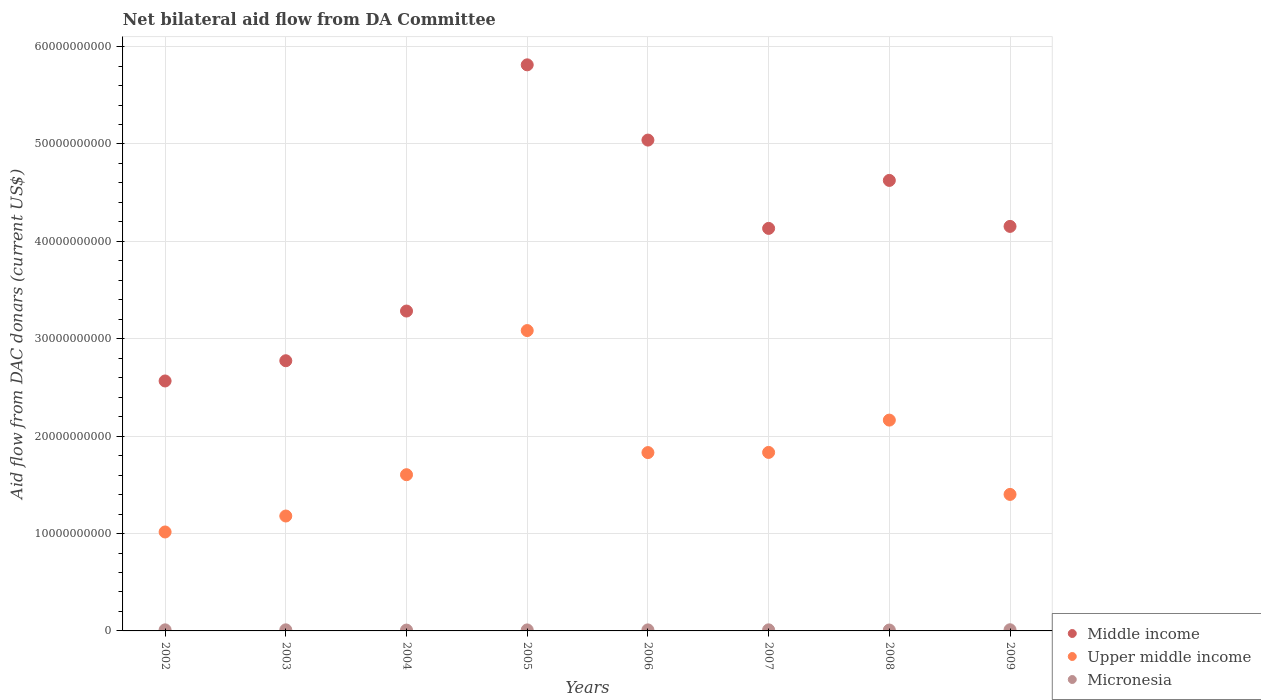Is the number of dotlines equal to the number of legend labels?
Make the answer very short. Yes. What is the aid flow in in Upper middle income in 2004?
Offer a terse response. 1.60e+1. Across all years, what is the maximum aid flow in in Middle income?
Offer a very short reply. 5.81e+1. Across all years, what is the minimum aid flow in in Middle income?
Provide a succinct answer. 2.57e+1. In which year was the aid flow in in Upper middle income maximum?
Offer a terse response. 2005. In which year was the aid flow in in Upper middle income minimum?
Make the answer very short. 2002. What is the total aid flow in in Upper middle income in the graph?
Your response must be concise. 1.41e+11. What is the difference between the aid flow in in Middle income in 2002 and that in 2004?
Offer a very short reply. -7.18e+09. What is the difference between the aid flow in in Micronesia in 2004 and the aid flow in in Middle income in 2008?
Make the answer very short. -4.62e+1. What is the average aid flow in in Upper middle income per year?
Give a very brief answer. 1.76e+1. In the year 2006, what is the difference between the aid flow in in Upper middle income and aid flow in in Micronesia?
Give a very brief answer. 1.82e+1. In how many years, is the aid flow in in Micronesia greater than 24000000000 US$?
Provide a succinct answer. 0. What is the ratio of the aid flow in in Middle income in 2006 to that in 2008?
Your response must be concise. 1.09. Is the aid flow in in Middle income in 2005 less than that in 2007?
Provide a short and direct response. No. What is the difference between the highest and the second highest aid flow in in Middle income?
Your answer should be very brief. 7.73e+09. What is the difference between the highest and the lowest aid flow in in Middle income?
Provide a short and direct response. 3.25e+1. In how many years, is the aid flow in in Micronesia greater than the average aid flow in in Micronesia taken over all years?
Offer a terse response. 5. Is it the case that in every year, the sum of the aid flow in in Middle income and aid flow in in Upper middle income  is greater than the aid flow in in Micronesia?
Your response must be concise. Yes. Is the aid flow in in Middle income strictly less than the aid flow in in Micronesia over the years?
Offer a terse response. No. What is the difference between two consecutive major ticks on the Y-axis?
Give a very brief answer. 1.00e+1. Are the values on the major ticks of Y-axis written in scientific E-notation?
Keep it short and to the point. No. Does the graph contain grids?
Offer a very short reply. Yes. How many legend labels are there?
Provide a succinct answer. 3. What is the title of the graph?
Ensure brevity in your answer.  Net bilateral aid flow from DA Committee. Does "Croatia" appear as one of the legend labels in the graph?
Keep it short and to the point. No. What is the label or title of the X-axis?
Give a very brief answer. Years. What is the label or title of the Y-axis?
Provide a short and direct response. Aid flow from DAC donars (current US$). What is the Aid flow from DAC donars (current US$) of Middle income in 2002?
Your answer should be compact. 2.57e+1. What is the Aid flow from DAC donars (current US$) in Upper middle income in 2002?
Your response must be concise. 1.02e+1. What is the Aid flow from DAC donars (current US$) of Micronesia in 2002?
Your answer should be very brief. 1.10e+08. What is the Aid flow from DAC donars (current US$) in Middle income in 2003?
Offer a very short reply. 2.77e+1. What is the Aid flow from DAC donars (current US$) in Upper middle income in 2003?
Your response must be concise. 1.18e+1. What is the Aid flow from DAC donars (current US$) in Micronesia in 2003?
Provide a short and direct response. 1.12e+08. What is the Aid flow from DAC donars (current US$) in Middle income in 2004?
Ensure brevity in your answer.  3.28e+1. What is the Aid flow from DAC donars (current US$) of Upper middle income in 2004?
Keep it short and to the point. 1.60e+1. What is the Aid flow from DAC donars (current US$) in Micronesia in 2004?
Your response must be concise. 8.52e+07. What is the Aid flow from DAC donars (current US$) in Middle income in 2005?
Keep it short and to the point. 5.81e+1. What is the Aid flow from DAC donars (current US$) in Upper middle income in 2005?
Your answer should be compact. 3.08e+1. What is the Aid flow from DAC donars (current US$) of Micronesia in 2005?
Make the answer very short. 1.04e+08. What is the Aid flow from DAC donars (current US$) of Middle income in 2006?
Offer a terse response. 5.04e+1. What is the Aid flow from DAC donars (current US$) of Upper middle income in 2006?
Offer a terse response. 1.83e+1. What is the Aid flow from DAC donars (current US$) of Micronesia in 2006?
Your answer should be compact. 1.06e+08. What is the Aid flow from DAC donars (current US$) in Middle income in 2007?
Offer a very short reply. 4.13e+1. What is the Aid flow from DAC donars (current US$) in Upper middle income in 2007?
Your answer should be very brief. 1.83e+1. What is the Aid flow from DAC donars (current US$) in Micronesia in 2007?
Offer a terse response. 1.11e+08. What is the Aid flow from DAC donars (current US$) of Middle income in 2008?
Provide a succinct answer. 4.63e+1. What is the Aid flow from DAC donars (current US$) in Upper middle income in 2008?
Your response must be concise. 2.16e+1. What is the Aid flow from DAC donars (current US$) of Micronesia in 2008?
Keep it short and to the point. 9.08e+07. What is the Aid flow from DAC donars (current US$) in Middle income in 2009?
Offer a terse response. 4.15e+1. What is the Aid flow from DAC donars (current US$) in Upper middle income in 2009?
Offer a terse response. 1.40e+1. What is the Aid flow from DAC donars (current US$) of Micronesia in 2009?
Make the answer very short. 1.21e+08. Across all years, what is the maximum Aid flow from DAC donars (current US$) in Middle income?
Your response must be concise. 5.81e+1. Across all years, what is the maximum Aid flow from DAC donars (current US$) of Upper middle income?
Give a very brief answer. 3.08e+1. Across all years, what is the maximum Aid flow from DAC donars (current US$) of Micronesia?
Ensure brevity in your answer.  1.21e+08. Across all years, what is the minimum Aid flow from DAC donars (current US$) of Middle income?
Offer a terse response. 2.57e+1. Across all years, what is the minimum Aid flow from DAC donars (current US$) of Upper middle income?
Offer a terse response. 1.02e+1. Across all years, what is the minimum Aid flow from DAC donars (current US$) of Micronesia?
Keep it short and to the point. 8.52e+07. What is the total Aid flow from DAC donars (current US$) in Middle income in the graph?
Your answer should be very brief. 3.24e+11. What is the total Aid flow from DAC donars (current US$) in Upper middle income in the graph?
Offer a terse response. 1.41e+11. What is the total Aid flow from DAC donars (current US$) in Micronesia in the graph?
Provide a succinct answer. 8.41e+08. What is the difference between the Aid flow from DAC donars (current US$) of Middle income in 2002 and that in 2003?
Offer a terse response. -2.08e+09. What is the difference between the Aid flow from DAC donars (current US$) of Upper middle income in 2002 and that in 2003?
Your answer should be compact. -1.64e+09. What is the difference between the Aid flow from DAC donars (current US$) of Micronesia in 2002 and that in 2003?
Give a very brief answer. -1.82e+06. What is the difference between the Aid flow from DAC donars (current US$) of Middle income in 2002 and that in 2004?
Your answer should be very brief. -7.18e+09. What is the difference between the Aid flow from DAC donars (current US$) of Upper middle income in 2002 and that in 2004?
Your answer should be compact. -5.88e+09. What is the difference between the Aid flow from DAC donars (current US$) of Micronesia in 2002 and that in 2004?
Provide a short and direct response. 2.49e+07. What is the difference between the Aid flow from DAC donars (current US$) of Middle income in 2002 and that in 2005?
Provide a short and direct response. -3.25e+1. What is the difference between the Aid flow from DAC donars (current US$) of Upper middle income in 2002 and that in 2005?
Keep it short and to the point. -2.07e+1. What is the difference between the Aid flow from DAC donars (current US$) in Micronesia in 2002 and that in 2005?
Keep it short and to the point. 5.66e+06. What is the difference between the Aid flow from DAC donars (current US$) of Middle income in 2002 and that in 2006?
Make the answer very short. -2.47e+1. What is the difference between the Aid flow from DAC donars (current US$) of Upper middle income in 2002 and that in 2006?
Your response must be concise. -8.15e+09. What is the difference between the Aid flow from DAC donars (current US$) of Micronesia in 2002 and that in 2006?
Give a very brief answer. 4.03e+06. What is the difference between the Aid flow from DAC donars (current US$) of Middle income in 2002 and that in 2007?
Offer a very short reply. -1.57e+1. What is the difference between the Aid flow from DAC donars (current US$) in Upper middle income in 2002 and that in 2007?
Keep it short and to the point. -8.17e+09. What is the difference between the Aid flow from DAC donars (current US$) of Micronesia in 2002 and that in 2007?
Your answer should be compact. -1.27e+06. What is the difference between the Aid flow from DAC donars (current US$) of Middle income in 2002 and that in 2008?
Offer a terse response. -2.06e+1. What is the difference between the Aid flow from DAC donars (current US$) of Upper middle income in 2002 and that in 2008?
Provide a succinct answer. -1.15e+1. What is the difference between the Aid flow from DAC donars (current US$) in Micronesia in 2002 and that in 2008?
Provide a short and direct response. 1.92e+07. What is the difference between the Aid flow from DAC donars (current US$) of Middle income in 2002 and that in 2009?
Make the answer very short. -1.59e+1. What is the difference between the Aid flow from DAC donars (current US$) of Upper middle income in 2002 and that in 2009?
Give a very brief answer. -3.86e+09. What is the difference between the Aid flow from DAC donars (current US$) in Micronesia in 2002 and that in 2009?
Offer a very short reply. -1.08e+07. What is the difference between the Aid flow from DAC donars (current US$) in Middle income in 2003 and that in 2004?
Your answer should be compact. -5.10e+09. What is the difference between the Aid flow from DAC donars (current US$) of Upper middle income in 2003 and that in 2004?
Provide a short and direct response. -4.24e+09. What is the difference between the Aid flow from DAC donars (current US$) in Micronesia in 2003 and that in 2004?
Keep it short and to the point. 2.67e+07. What is the difference between the Aid flow from DAC donars (current US$) of Middle income in 2003 and that in 2005?
Make the answer very short. -3.04e+1. What is the difference between the Aid flow from DAC donars (current US$) of Upper middle income in 2003 and that in 2005?
Keep it short and to the point. -1.90e+1. What is the difference between the Aid flow from DAC donars (current US$) in Micronesia in 2003 and that in 2005?
Make the answer very short. 7.48e+06. What is the difference between the Aid flow from DAC donars (current US$) in Middle income in 2003 and that in 2006?
Provide a succinct answer. -2.27e+1. What is the difference between the Aid flow from DAC donars (current US$) of Upper middle income in 2003 and that in 2006?
Make the answer very short. -6.51e+09. What is the difference between the Aid flow from DAC donars (current US$) of Micronesia in 2003 and that in 2006?
Make the answer very short. 5.85e+06. What is the difference between the Aid flow from DAC donars (current US$) of Middle income in 2003 and that in 2007?
Ensure brevity in your answer.  -1.36e+1. What is the difference between the Aid flow from DAC donars (current US$) in Upper middle income in 2003 and that in 2007?
Your response must be concise. -6.53e+09. What is the difference between the Aid flow from DAC donars (current US$) of Micronesia in 2003 and that in 2007?
Offer a very short reply. 5.50e+05. What is the difference between the Aid flow from DAC donars (current US$) of Middle income in 2003 and that in 2008?
Provide a succinct answer. -1.85e+1. What is the difference between the Aid flow from DAC donars (current US$) of Upper middle income in 2003 and that in 2008?
Keep it short and to the point. -9.85e+09. What is the difference between the Aid flow from DAC donars (current US$) in Micronesia in 2003 and that in 2008?
Give a very brief answer. 2.10e+07. What is the difference between the Aid flow from DAC donars (current US$) in Middle income in 2003 and that in 2009?
Ensure brevity in your answer.  -1.38e+1. What is the difference between the Aid flow from DAC donars (current US$) in Upper middle income in 2003 and that in 2009?
Make the answer very short. -2.22e+09. What is the difference between the Aid flow from DAC donars (current US$) in Micronesia in 2003 and that in 2009?
Ensure brevity in your answer.  -9.02e+06. What is the difference between the Aid flow from DAC donars (current US$) of Middle income in 2004 and that in 2005?
Provide a succinct answer. -2.53e+1. What is the difference between the Aid flow from DAC donars (current US$) of Upper middle income in 2004 and that in 2005?
Make the answer very short. -1.48e+1. What is the difference between the Aid flow from DAC donars (current US$) in Micronesia in 2004 and that in 2005?
Your response must be concise. -1.92e+07. What is the difference between the Aid flow from DAC donars (current US$) in Middle income in 2004 and that in 2006?
Make the answer very short. -1.76e+1. What is the difference between the Aid flow from DAC donars (current US$) in Upper middle income in 2004 and that in 2006?
Your answer should be very brief. -2.27e+09. What is the difference between the Aid flow from DAC donars (current US$) of Micronesia in 2004 and that in 2006?
Your answer should be compact. -2.09e+07. What is the difference between the Aid flow from DAC donars (current US$) in Middle income in 2004 and that in 2007?
Your answer should be very brief. -8.49e+09. What is the difference between the Aid flow from DAC donars (current US$) of Upper middle income in 2004 and that in 2007?
Provide a succinct answer. -2.29e+09. What is the difference between the Aid flow from DAC donars (current US$) in Micronesia in 2004 and that in 2007?
Offer a terse response. -2.62e+07. What is the difference between the Aid flow from DAC donars (current US$) of Middle income in 2004 and that in 2008?
Keep it short and to the point. -1.34e+1. What is the difference between the Aid flow from DAC donars (current US$) in Upper middle income in 2004 and that in 2008?
Your answer should be compact. -5.61e+09. What is the difference between the Aid flow from DAC donars (current US$) in Micronesia in 2004 and that in 2008?
Provide a succinct answer. -5.68e+06. What is the difference between the Aid flow from DAC donars (current US$) in Middle income in 2004 and that in 2009?
Provide a short and direct response. -8.69e+09. What is the difference between the Aid flow from DAC donars (current US$) of Upper middle income in 2004 and that in 2009?
Provide a short and direct response. 2.02e+09. What is the difference between the Aid flow from DAC donars (current US$) in Micronesia in 2004 and that in 2009?
Offer a terse response. -3.57e+07. What is the difference between the Aid flow from DAC donars (current US$) of Middle income in 2005 and that in 2006?
Ensure brevity in your answer.  7.73e+09. What is the difference between the Aid flow from DAC donars (current US$) in Upper middle income in 2005 and that in 2006?
Make the answer very short. 1.25e+1. What is the difference between the Aid flow from DAC donars (current US$) of Micronesia in 2005 and that in 2006?
Offer a terse response. -1.63e+06. What is the difference between the Aid flow from DAC donars (current US$) of Middle income in 2005 and that in 2007?
Your answer should be very brief. 1.68e+1. What is the difference between the Aid flow from DAC donars (current US$) of Upper middle income in 2005 and that in 2007?
Your answer should be compact. 1.25e+1. What is the difference between the Aid flow from DAC donars (current US$) of Micronesia in 2005 and that in 2007?
Your answer should be compact. -6.93e+06. What is the difference between the Aid flow from DAC donars (current US$) in Middle income in 2005 and that in 2008?
Keep it short and to the point. 1.19e+1. What is the difference between the Aid flow from DAC donars (current US$) of Upper middle income in 2005 and that in 2008?
Offer a very short reply. 9.19e+09. What is the difference between the Aid flow from DAC donars (current US$) in Micronesia in 2005 and that in 2008?
Offer a terse response. 1.36e+07. What is the difference between the Aid flow from DAC donars (current US$) in Middle income in 2005 and that in 2009?
Ensure brevity in your answer.  1.66e+1. What is the difference between the Aid flow from DAC donars (current US$) in Upper middle income in 2005 and that in 2009?
Your answer should be very brief. 1.68e+1. What is the difference between the Aid flow from DAC donars (current US$) in Micronesia in 2005 and that in 2009?
Provide a succinct answer. -1.65e+07. What is the difference between the Aid flow from DAC donars (current US$) in Middle income in 2006 and that in 2007?
Offer a very short reply. 9.07e+09. What is the difference between the Aid flow from DAC donars (current US$) of Upper middle income in 2006 and that in 2007?
Keep it short and to the point. -1.82e+07. What is the difference between the Aid flow from DAC donars (current US$) of Micronesia in 2006 and that in 2007?
Your answer should be compact. -5.30e+06. What is the difference between the Aid flow from DAC donars (current US$) in Middle income in 2006 and that in 2008?
Your response must be concise. 4.14e+09. What is the difference between the Aid flow from DAC donars (current US$) in Upper middle income in 2006 and that in 2008?
Your answer should be compact. -3.34e+09. What is the difference between the Aid flow from DAC donars (current US$) in Micronesia in 2006 and that in 2008?
Provide a short and direct response. 1.52e+07. What is the difference between the Aid flow from DAC donars (current US$) of Middle income in 2006 and that in 2009?
Provide a short and direct response. 8.86e+09. What is the difference between the Aid flow from DAC donars (current US$) of Upper middle income in 2006 and that in 2009?
Offer a very short reply. 4.29e+09. What is the difference between the Aid flow from DAC donars (current US$) in Micronesia in 2006 and that in 2009?
Keep it short and to the point. -1.49e+07. What is the difference between the Aid flow from DAC donars (current US$) of Middle income in 2007 and that in 2008?
Provide a short and direct response. -4.93e+09. What is the difference between the Aid flow from DAC donars (current US$) of Upper middle income in 2007 and that in 2008?
Give a very brief answer. -3.32e+09. What is the difference between the Aid flow from DAC donars (current US$) of Micronesia in 2007 and that in 2008?
Give a very brief answer. 2.05e+07. What is the difference between the Aid flow from DAC donars (current US$) of Middle income in 2007 and that in 2009?
Offer a terse response. -2.05e+08. What is the difference between the Aid flow from DAC donars (current US$) of Upper middle income in 2007 and that in 2009?
Give a very brief answer. 4.31e+09. What is the difference between the Aid flow from DAC donars (current US$) in Micronesia in 2007 and that in 2009?
Give a very brief answer. -9.57e+06. What is the difference between the Aid flow from DAC donars (current US$) in Middle income in 2008 and that in 2009?
Keep it short and to the point. 4.72e+09. What is the difference between the Aid flow from DAC donars (current US$) in Upper middle income in 2008 and that in 2009?
Your answer should be very brief. 7.63e+09. What is the difference between the Aid flow from DAC donars (current US$) in Micronesia in 2008 and that in 2009?
Offer a terse response. -3.01e+07. What is the difference between the Aid flow from DAC donars (current US$) in Middle income in 2002 and the Aid flow from DAC donars (current US$) in Upper middle income in 2003?
Your response must be concise. 1.39e+1. What is the difference between the Aid flow from DAC donars (current US$) of Middle income in 2002 and the Aid flow from DAC donars (current US$) of Micronesia in 2003?
Your answer should be compact. 2.56e+1. What is the difference between the Aid flow from DAC donars (current US$) of Upper middle income in 2002 and the Aid flow from DAC donars (current US$) of Micronesia in 2003?
Your answer should be compact. 1.00e+1. What is the difference between the Aid flow from DAC donars (current US$) of Middle income in 2002 and the Aid flow from DAC donars (current US$) of Upper middle income in 2004?
Offer a very short reply. 9.63e+09. What is the difference between the Aid flow from DAC donars (current US$) in Middle income in 2002 and the Aid flow from DAC donars (current US$) in Micronesia in 2004?
Provide a short and direct response. 2.56e+1. What is the difference between the Aid flow from DAC donars (current US$) in Upper middle income in 2002 and the Aid flow from DAC donars (current US$) in Micronesia in 2004?
Make the answer very short. 1.01e+1. What is the difference between the Aid flow from DAC donars (current US$) of Middle income in 2002 and the Aid flow from DAC donars (current US$) of Upper middle income in 2005?
Give a very brief answer. -5.17e+09. What is the difference between the Aid flow from DAC donars (current US$) of Middle income in 2002 and the Aid flow from DAC donars (current US$) of Micronesia in 2005?
Your answer should be very brief. 2.56e+1. What is the difference between the Aid flow from DAC donars (current US$) of Upper middle income in 2002 and the Aid flow from DAC donars (current US$) of Micronesia in 2005?
Provide a succinct answer. 1.01e+1. What is the difference between the Aid flow from DAC donars (current US$) in Middle income in 2002 and the Aid flow from DAC donars (current US$) in Upper middle income in 2006?
Keep it short and to the point. 7.35e+09. What is the difference between the Aid flow from DAC donars (current US$) of Middle income in 2002 and the Aid flow from DAC donars (current US$) of Micronesia in 2006?
Your response must be concise. 2.56e+1. What is the difference between the Aid flow from DAC donars (current US$) of Upper middle income in 2002 and the Aid flow from DAC donars (current US$) of Micronesia in 2006?
Give a very brief answer. 1.01e+1. What is the difference between the Aid flow from DAC donars (current US$) in Middle income in 2002 and the Aid flow from DAC donars (current US$) in Upper middle income in 2007?
Ensure brevity in your answer.  7.34e+09. What is the difference between the Aid flow from DAC donars (current US$) of Middle income in 2002 and the Aid flow from DAC donars (current US$) of Micronesia in 2007?
Ensure brevity in your answer.  2.56e+1. What is the difference between the Aid flow from DAC donars (current US$) of Upper middle income in 2002 and the Aid flow from DAC donars (current US$) of Micronesia in 2007?
Provide a succinct answer. 1.00e+1. What is the difference between the Aid flow from DAC donars (current US$) in Middle income in 2002 and the Aid flow from DAC donars (current US$) in Upper middle income in 2008?
Your answer should be compact. 4.02e+09. What is the difference between the Aid flow from DAC donars (current US$) of Middle income in 2002 and the Aid flow from DAC donars (current US$) of Micronesia in 2008?
Your answer should be compact. 2.56e+1. What is the difference between the Aid flow from DAC donars (current US$) in Upper middle income in 2002 and the Aid flow from DAC donars (current US$) in Micronesia in 2008?
Provide a short and direct response. 1.01e+1. What is the difference between the Aid flow from DAC donars (current US$) in Middle income in 2002 and the Aid flow from DAC donars (current US$) in Upper middle income in 2009?
Keep it short and to the point. 1.16e+1. What is the difference between the Aid flow from DAC donars (current US$) of Middle income in 2002 and the Aid flow from DAC donars (current US$) of Micronesia in 2009?
Offer a terse response. 2.55e+1. What is the difference between the Aid flow from DAC donars (current US$) in Upper middle income in 2002 and the Aid flow from DAC donars (current US$) in Micronesia in 2009?
Give a very brief answer. 1.00e+1. What is the difference between the Aid flow from DAC donars (current US$) in Middle income in 2003 and the Aid flow from DAC donars (current US$) in Upper middle income in 2004?
Your response must be concise. 1.17e+1. What is the difference between the Aid flow from DAC donars (current US$) in Middle income in 2003 and the Aid flow from DAC donars (current US$) in Micronesia in 2004?
Make the answer very short. 2.77e+1. What is the difference between the Aid flow from DAC donars (current US$) in Upper middle income in 2003 and the Aid flow from DAC donars (current US$) in Micronesia in 2004?
Provide a succinct answer. 1.17e+1. What is the difference between the Aid flow from DAC donars (current US$) in Middle income in 2003 and the Aid flow from DAC donars (current US$) in Upper middle income in 2005?
Your answer should be compact. -3.10e+09. What is the difference between the Aid flow from DAC donars (current US$) of Middle income in 2003 and the Aid flow from DAC donars (current US$) of Micronesia in 2005?
Ensure brevity in your answer.  2.76e+1. What is the difference between the Aid flow from DAC donars (current US$) of Upper middle income in 2003 and the Aid flow from DAC donars (current US$) of Micronesia in 2005?
Your response must be concise. 1.17e+1. What is the difference between the Aid flow from DAC donars (current US$) of Middle income in 2003 and the Aid flow from DAC donars (current US$) of Upper middle income in 2006?
Your answer should be very brief. 9.43e+09. What is the difference between the Aid flow from DAC donars (current US$) of Middle income in 2003 and the Aid flow from DAC donars (current US$) of Micronesia in 2006?
Make the answer very short. 2.76e+1. What is the difference between the Aid flow from DAC donars (current US$) in Upper middle income in 2003 and the Aid flow from DAC donars (current US$) in Micronesia in 2006?
Ensure brevity in your answer.  1.17e+1. What is the difference between the Aid flow from DAC donars (current US$) of Middle income in 2003 and the Aid flow from DAC donars (current US$) of Upper middle income in 2007?
Your answer should be very brief. 9.41e+09. What is the difference between the Aid flow from DAC donars (current US$) in Middle income in 2003 and the Aid flow from DAC donars (current US$) in Micronesia in 2007?
Provide a short and direct response. 2.76e+1. What is the difference between the Aid flow from DAC donars (current US$) of Upper middle income in 2003 and the Aid flow from DAC donars (current US$) of Micronesia in 2007?
Keep it short and to the point. 1.17e+1. What is the difference between the Aid flow from DAC donars (current US$) in Middle income in 2003 and the Aid flow from DAC donars (current US$) in Upper middle income in 2008?
Offer a terse response. 6.10e+09. What is the difference between the Aid flow from DAC donars (current US$) in Middle income in 2003 and the Aid flow from DAC donars (current US$) in Micronesia in 2008?
Your response must be concise. 2.77e+1. What is the difference between the Aid flow from DAC donars (current US$) of Upper middle income in 2003 and the Aid flow from DAC donars (current US$) of Micronesia in 2008?
Offer a terse response. 1.17e+1. What is the difference between the Aid flow from DAC donars (current US$) in Middle income in 2003 and the Aid flow from DAC donars (current US$) in Upper middle income in 2009?
Ensure brevity in your answer.  1.37e+1. What is the difference between the Aid flow from DAC donars (current US$) of Middle income in 2003 and the Aid flow from DAC donars (current US$) of Micronesia in 2009?
Ensure brevity in your answer.  2.76e+1. What is the difference between the Aid flow from DAC donars (current US$) of Upper middle income in 2003 and the Aid flow from DAC donars (current US$) of Micronesia in 2009?
Provide a succinct answer. 1.17e+1. What is the difference between the Aid flow from DAC donars (current US$) of Middle income in 2004 and the Aid flow from DAC donars (current US$) of Upper middle income in 2005?
Make the answer very short. 2.01e+09. What is the difference between the Aid flow from DAC donars (current US$) of Middle income in 2004 and the Aid flow from DAC donars (current US$) of Micronesia in 2005?
Your response must be concise. 3.27e+1. What is the difference between the Aid flow from DAC donars (current US$) of Upper middle income in 2004 and the Aid flow from DAC donars (current US$) of Micronesia in 2005?
Offer a terse response. 1.59e+1. What is the difference between the Aid flow from DAC donars (current US$) in Middle income in 2004 and the Aid flow from DAC donars (current US$) in Upper middle income in 2006?
Keep it short and to the point. 1.45e+1. What is the difference between the Aid flow from DAC donars (current US$) in Middle income in 2004 and the Aid flow from DAC donars (current US$) in Micronesia in 2006?
Ensure brevity in your answer.  3.27e+1. What is the difference between the Aid flow from DAC donars (current US$) in Upper middle income in 2004 and the Aid flow from DAC donars (current US$) in Micronesia in 2006?
Offer a very short reply. 1.59e+1. What is the difference between the Aid flow from DAC donars (current US$) of Middle income in 2004 and the Aid flow from DAC donars (current US$) of Upper middle income in 2007?
Ensure brevity in your answer.  1.45e+1. What is the difference between the Aid flow from DAC donars (current US$) in Middle income in 2004 and the Aid flow from DAC donars (current US$) in Micronesia in 2007?
Your answer should be very brief. 3.27e+1. What is the difference between the Aid flow from DAC donars (current US$) in Upper middle income in 2004 and the Aid flow from DAC donars (current US$) in Micronesia in 2007?
Provide a short and direct response. 1.59e+1. What is the difference between the Aid flow from DAC donars (current US$) of Middle income in 2004 and the Aid flow from DAC donars (current US$) of Upper middle income in 2008?
Make the answer very short. 1.12e+1. What is the difference between the Aid flow from DAC donars (current US$) of Middle income in 2004 and the Aid flow from DAC donars (current US$) of Micronesia in 2008?
Provide a short and direct response. 3.28e+1. What is the difference between the Aid flow from DAC donars (current US$) in Upper middle income in 2004 and the Aid flow from DAC donars (current US$) in Micronesia in 2008?
Offer a terse response. 1.59e+1. What is the difference between the Aid flow from DAC donars (current US$) in Middle income in 2004 and the Aid flow from DAC donars (current US$) in Upper middle income in 2009?
Your response must be concise. 1.88e+1. What is the difference between the Aid flow from DAC donars (current US$) of Middle income in 2004 and the Aid flow from DAC donars (current US$) of Micronesia in 2009?
Offer a terse response. 3.27e+1. What is the difference between the Aid flow from DAC donars (current US$) in Upper middle income in 2004 and the Aid flow from DAC donars (current US$) in Micronesia in 2009?
Offer a very short reply. 1.59e+1. What is the difference between the Aid flow from DAC donars (current US$) of Middle income in 2005 and the Aid flow from DAC donars (current US$) of Upper middle income in 2006?
Your answer should be compact. 3.98e+1. What is the difference between the Aid flow from DAC donars (current US$) of Middle income in 2005 and the Aid flow from DAC donars (current US$) of Micronesia in 2006?
Give a very brief answer. 5.80e+1. What is the difference between the Aid flow from DAC donars (current US$) of Upper middle income in 2005 and the Aid flow from DAC donars (current US$) of Micronesia in 2006?
Your response must be concise. 3.07e+1. What is the difference between the Aid flow from DAC donars (current US$) in Middle income in 2005 and the Aid flow from DAC donars (current US$) in Upper middle income in 2007?
Offer a very short reply. 3.98e+1. What is the difference between the Aid flow from DAC donars (current US$) of Middle income in 2005 and the Aid flow from DAC donars (current US$) of Micronesia in 2007?
Provide a succinct answer. 5.80e+1. What is the difference between the Aid flow from DAC donars (current US$) of Upper middle income in 2005 and the Aid flow from DAC donars (current US$) of Micronesia in 2007?
Provide a succinct answer. 3.07e+1. What is the difference between the Aid flow from DAC donars (current US$) of Middle income in 2005 and the Aid flow from DAC donars (current US$) of Upper middle income in 2008?
Make the answer very short. 3.65e+1. What is the difference between the Aid flow from DAC donars (current US$) in Middle income in 2005 and the Aid flow from DAC donars (current US$) in Micronesia in 2008?
Provide a succinct answer. 5.80e+1. What is the difference between the Aid flow from DAC donars (current US$) in Upper middle income in 2005 and the Aid flow from DAC donars (current US$) in Micronesia in 2008?
Give a very brief answer. 3.07e+1. What is the difference between the Aid flow from DAC donars (current US$) in Middle income in 2005 and the Aid flow from DAC donars (current US$) in Upper middle income in 2009?
Ensure brevity in your answer.  4.41e+1. What is the difference between the Aid flow from DAC donars (current US$) of Middle income in 2005 and the Aid flow from DAC donars (current US$) of Micronesia in 2009?
Your answer should be very brief. 5.80e+1. What is the difference between the Aid flow from DAC donars (current US$) of Upper middle income in 2005 and the Aid flow from DAC donars (current US$) of Micronesia in 2009?
Make the answer very short. 3.07e+1. What is the difference between the Aid flow from DAC donars (current US$) of Middle income in 2006 and the Aid flow from DAC donars (current US$) of Upper middle income in 2007?
Keep it short and to the point. 3.21e+1. What is the difference between the Aid flow from DAC donars (current US$) in Middle income in 2006 and the Aid flow from DAC donars (current US$) in Micronesia in 2007?
Provide a short and direct response. 5.03e+1. What is the difference between the Aid flow from DAC donars (current US$) of Upper middle income in 2006 and the Aid flow from DAC donars (current US$) of Micronesia in 2007?
Make the answer very short. 1.82e+1. What is the difference between the Aid flow from DAC donars (current US$) in Middle income in 2006 and the Aid flow from DAC donars (current US$) in Upper middle income in 2008?
Offer a terse response. 2.88e+1. What is the difference between the Aid flow from DAC donars (current US$) in Middle income in 2006 and the Aid flow from DAC donars (current US$) in Micronesia in 2008?
Give a very brief answer. 5.03e+1. What is the difference between the Aid flow from DAC donars (current US$) of Upper middle income in 2006 and the Aid flow from DAC donars (current US$) of Micronesia in 2008?
Your answer should be compact. 1.82e+1. What is the difference between the Aid flow from DAC donars (current US$) of Middle income in 2006 and the Aid flow from DAC donars (current US$) of Upper middle income in 2009?
Your response must be concise. 3.64e+1. What is the difference between the Aid flow from DAC donars (current US$) of Middle income in 2006 and the Aid flow from DAC donars (current US$) of Micronesia in 2009?
Make the answer very short. 5.03e+1. What is the difference between the Aid flow from DAC donars (current US$) of Upper middle income in 2006 and the Aid flow from DAC donars (current US$) of Micronesia in 2009?
Keep it short and to the point. 1.82e+1. What is the difference between the Aid flow from DAC donars (current US$) of Middle income in 2007 and the Aid flow from DAC donars (current US$) of Upper middle income in 2008?
Offer a very short reply. 1.97e+1. What is the difference between the Aid flow from DAC donars (current US$) of Middle income in 2007 and the Aid flow from DAC donars (current US$) of Micronesia in 2008?
Ensure brevity in your answer.  4.12e+1. What is the difference between the Aid flow from DAC donars (current US$) in Upper middle income in 2007 and the Aid flow from DAC donars (current US$) in Micronesia in 2008?
Your answer should be very brief. 1.82e+1. What is the difference between the Aid flow from DAC donars (current US$) of Middle income in 2007 and the Aid flow from DAC donars (current US$) of Upper middle income in 2009?
Provide a short and direct response. 2.73e+1. What is the difference between the Aid flow from DAC donars (current US$) in Middle income in 2007 and the Aid flow from DAC donars (current US$) in Micronesia in 2009?
Offer a terse response. 4.12e+1. What is the difference between the Aid flow from DAC donars (current US$) in Upper middle income in 2007 and the Aid flow from DAC donars (current US$) in Micronesia in 2009?
Make the answer very short. 1.82e+1. What is the difference between the Aid flow from DAC donars (current US$) of Middle income in 2008 and the Aid flow from DAC donars (current US$) of Upper middle income in 2009?
Offer a terse response. 3.22e+1. What is the difference between the Aid flow from DAC donars (current US$) of Middle income in 2008 and the Aid flow from DAC donars (current US$) of Micronesia in 2009?
Make the answer very short. 4.61e+1. What is the difference between the Aid flow from DAC donars (current US$) of Upper middle income in 2008 and the Aid flow from DAC donars (current US$) of Micronesia in 2009?
Give a very brief answer. 2.15e+1. What is the average Aid flow from DAC donars (current US$) in Middle income per year?
Give a very brief answer. 4.05e+1. What is the average Aid flow from DAC donars (current US$) of Upper middle income per year?
Your answer should be very brief. 1.76e+1. What is the average Aid flow from DAC donars (current US$) of Micronesia per year?
Keep it short and to the point. 1.05e+08. In the year 2002, what is the difference between the Aid flow from DAC donars (current US$) of Middle income and Aid flow from DAC donars (current US$) of Upper middle income?
Provide a succinct answer. 1.55e+1. In the year 2002, what is the difference between the Aid flow from DAC donars (current US$) in Middle income and Aid flow from DAC donars (current US$) in Micronesia?
Your answer should be very brief. 2.56e+1. In the year 2002, what is the difference between the Aid flow from DAC donars (current US$) in Upper middle income and Aid flow from DAC donars (current US$) in Micronesia?
Ensure brevity in your answer.  1.01e+1. In the year 2003, what is the difference between the Aid flow from DAC donars (current US$) in Middle income and Aid flow from DAC donars (current US$) in Upper middle income?
Ensure brevity in your answer.  1.59e+1. In the year 2003, what is the difference between the Aid flow from DAC donars (current US$) in Middle income and Aid flow from DAC donars (current US$) in Micronesia?
Provide a succinct answer. 2.76e+1. In the year 2003, what is the difference between the Aid flow from DAC donars (current US$) of Upper middle income and Aid flow from DAC donars (current US$) of Micronesia?
Make the answer very short. 1.17e+1. In the year 2004, what is the difference between the Aid flow from DAC donars (current US$) in Middle income and Aid flow from DAC donars (current US$) in Upper middle income?
Offer a very short reply. 1.68e+1. In the year 2004, what is the difference between the Aid flow from DAC donars (current US$) of Middle income and Aid flow from DAC donars (current US$) of Micronesia?
Ensure brevity in your answer.  3.28e+1. In the year 2004, what is the difference between the Aid flow from DAC donars (current US$) of Upper middle income and Aid flow from DAC donars (current US$) of Micronesia?
Offer a terse response. 1.60e+1. In the year 2005, what is the difference between the Aid flow from DAC donars (current US$) of Middle income and Aid flow from DAC donars (current US$) of Upper middle income?
Your response must be concise. 2.73e+1. In the year 2005, what is the difference between the Aid flow from DAC donars (current US$) in Middle income and Aid flow from DAC donars (current US$) in Micronesia?
Make the answer very short. 5.80e+1. In the year 2005, what is the difference between the Aid flow from DAC donars (current US$) of Upper middle income and Aid flow from DAC donars (current US$) of Micronesia?
Keep it short and to the point. 3.07e+1. In the year 2006, what is the difference between the Aid flow from DAC donars (current US$) of Middle income and Aid flow from DAC donars (current US$) of Upper middle income?
Offer a very short reply. 3.21e+1. In the year 2006, what is the difference between the Aid flow from DAC donars (current US$) of Middle income and Aid flow from DAC donars (current US$) of Micronesia?
Keep it short and to the point. 5.03e+1. In the year 2006, what is the difference between the Aid flow from DAC donars (current US$) of Upper middle income and Aid flow from DAC donars (current US$) of Micronesia?
Offer a very short reply. 1.82e+1. In the year 2007, what is the difference between the Aid flow from DAC donars (current US$) in Middle income and Aid flow from DAC donars (current US$) in Upper middle income?
Your answer should be compact. 2.30e+1. In the year 2007, what is the difference between the Aid flow from DAC donars (current US$) in Middle income and Aid flow from DAC donars (current US$) in Micronesia?
Make the answer very short. 4.12e+1. In the year 2007, what is the difference between the Aid flow from DAC donars (current US$) of Upper middle income and Aid flow from DAC donars (current US$) of Micronesia?
Offer a terse response. 1.82e+1. In the year 2008, what is the difference between the Aid flow from DAC donars (current US$) of Middle income and Aid flow from DAC donars (current US$) of Upper middle income?
Offer a terse response. 2.46e+1. In the year 2008, what is the difference between the Aid flow from DAC donars (current US$) of Middle income and Aid flow from DAC donars (current US$) of Micronesia?
Give a very brief answer. 4.62e+1. In the year 2008, what is the difference between the Aid flow from DAC donars (current US$) of Upper middle income and Aid flow from DAC donars (current US$) of Micronesia?
Your answer should be very brief. 2.16e+1. In the year 2009, what is the difference between the Aid flow from DAC donars (current US$) in Middle income and Aid flow from DAC donars (current US$) in Upper middle income?
Provide a succinct answer. 2.75e+1. In the year 2009, what is the difference between the Aid flow from DAC donars (current US$) in Middle income and Aid flow from DAC donars (current US$) in Micronesia?
Your answer should be compact. 4.14e+1. In the year 2009, what is the difference between the Aid flow from DAC donars (current US$) in Upper middle income and Aid flow from DAC donars (current US$) in Micronesia?
Provide a short and direct response. 1.39e+1. What is the ratio of the Aid flow from DAC donars (current US$) in Middle income in 2002 to that in 2003?
Ensure brevity in your answer.  0.93. What is the ratio of the Aid flow from DAC donars (current US$) of Upper middle income in 2002 to that in 2003?
Provide a short and direct response. 0.86. What is the ratio of the Aid flow from DAC donars (current US$) of Micronesia in 2002 to that in 2003?
Provide a succinct answer. 0.98. What is the ratio of the Aid flow from DAC donars (current US$) in Middle income in 2002 to that in 2004?
Provide a succinct answer. 0.78. What is the ratio of the Aid flow from DAC donars (current US$) of Upper middle income in 2002 to that in 2004?
Offer a terse response. 0.63. What is the ratio of the Aid flow from DAC donars (current US$) in Micronesia in 2002 to that in 2004?
Ensure brevity in your answer.  1.29. What is the ratio of the Aid flow from DAC donars (current US$) of Middle income in 2002 to that in 2005?
Offer a terse response. 0.44. What is the ratio of the Aid flow from DAC donars (current US$) in Upper middle income in 2002 to that in 2005?
Your answer should be compact. 0.33. What is the ratio of the Aid flow from DAC donars (current US$) of Micronesia in 2002 to that in 2005?
Offer a very short reply. 1.05. What is the ratio of the Aid flow from DAC donars (current US$) of Middle income in 2002 to that in 2006?
Give a very brief answer. 0.51. What is the ratio of the Aid flow from DAC donars (current US$) of Upper middle income in 2002 to that in 2006?
Your response must be concise. 0.55. What is the ratio of the Aid flow from DAC donars (current US$) in Micronesia in 2002 to that in 2006?
Give a very brief answer. 1.04. What is the ratio of the Aid flow from DAC donars (current US$) in Middle income in 2002 to that in 2007?
Keep it short and to the point. 0.62. What is the ratio of the Aid flow from DAC donars (current US$) in Upper middle income in 2002 to that in 2007?
Your response must be concise. 0.55. What is the ratio of the Aid flow from DAC donars (current US$) in Middle income in 2002 to that in 2008?
Give a very brief answer. 0.55. What is the ratio of the Aid flow from DAC donars (current US$) of Upper middle income in 2002 to that in 2008?
Offer a terse response. 0.47. What is the ratio of the Aid flow from DAC donars (current US$) of Micronesia in 2002 to that in 2008?
Your answer should be compact. 1.21. What is the ratio of the Aid flow from DAC donars (current US$) in Middle income in 2002 to that in 2009?
Offer a very short reply. 0.62. What is the ratio of the Aid flow from DAC donars (current US$) of Upper middle income in 2002 to that in 2009?
Provide a succinct answer. 0.72. What is the ratio of the Aid flow from DAC donars (current US$) in Micronesia in 2002 to that in 2009?
Give a very brief answer. 0.91. What is the ratio of the Aid flow from DAC donars (current US$) of Middle income in 2003 to that in 2004?
Give a very brief answer. 0.84. What is the ratio of the Aid flow from DAC donars (current US$) in Upper middle income in 2003 to that in 2004?
Your answer should be compact. 0.74. What is the ratio of the Aid flow from DAC donars (current US$) of Micronesia in 2003 to that in 2004?
Offer a very short reply. 1.31. What is the ratio of the Aid flow from DAC donars (current US$) in Middle income in 2003 to that in 2005?
Give a very brief answer. 0.48. What is the ratio of the Aid flow from DAC donars (current US$) in Upper middle income in 2003 to that in 2005?
Your response must be concise. 0.38. What is the ratio of the Aid flow from DAC donars (current US$) of Micronesia in 2003 to that in 2005?
Provide a succinct answer. 1.07. What is the ratio of the Aid flow from DAC donars (current US$) in Middle income in 2003 to that in 2006?
Give a very brief answer. 0.55. What is the ratio of the Aid flow from DAC donars (current US$) in Upper middle income in 2003 to that in 2006?
Your answer should be compact. 0.64. What is the ratio of the Aid flow from DAC donars (current US$) in Micronesia in 2003 to that in 2006?
Make the answer very short. 1.06. What is the ratio of the Aid flow from DAC donars (current US$) of Middle income in 2003 to that in 2007?
Your response must be concise. 0.67. What is the ratio of the Aid flow from DAC donars (current US$) of Upper middle income in 2003 to that in 2007?
Offer a terse response. 0.64. What is the ratio of the Aid flow from DAC donars (current US$) of Micronesia in 2003 to that in 2007?
Make the answer very short. 1. What is the ratio of the Aid flow from DAC donars (current US$) in Middle income in 2003 to that in 2008?
Ensure brevity in your answer.  0.6. What is the ratio of the Aid flow from DAC donars (current US$) of Upper middle income in 2003 to that in 2008?
Your answer should be very brief. 0.55. What is the ratio of the Aid flow from DAC donars (current US$) in Micronesia in 2003 to that in 2008?
Provide a succinct answer. 1.23. What is the ratio of the Aid flow from DAC donars (current US$) in Middle income in 2003 to that in 2009?
Keep it short and to the point. 0.67. What is the ratio of the Aid flow from DAC donars (current US$) in Upper middle income in 2003 to that in 2009?
Ensure brevity in your answer.  0.84. What is the ratio of the Aid flow from DAC donars (current US$) of Micronesia in 2003 to that in 2009?
Your answer should be very brief. 0.93. What is the ratio of the Aid flow from DAC donars (current US$) of Middle income in 2004 to that in 2005?
Your answer should be compact. 0.57. What is the ratio of the Aid flow from DAC donars (current US$) of Upper middle income in 2004 to that in 2005?
Provide a succinct answer. 0.52. What is the ratio of the Aid flow from DAC donars (current US$) in Micronesia in 2004 to that in 2005?
Give a very brief answer. 0.82. What is the ratio of the Aid flow from DAC donars (current US$) in Middle income in 2004 to that in 2006?
Give a very brief answer. 0.65. What is the ratio of the Aid flow from DAC donars (current US$) in Upper middle income in 2004 to that in 2006?
Offer a terse response. 0.88. What is the ratio of the Aid flow from DAC donars (current US$) of Micronesia in 2004 to that in 2006?
Your response must be concise. 0.8. What is the ratio of the Aid flow from DAC donars (current US$) of Middle income in 2004 to that in 2007?
Your response must be concise. 0.79. What is the ratio of the Aid flow from DAC donars (current US$) of Upper middle income in 2004 to that in 2007?
Provide a short and direct response. 0.88. What is the ratio of the Aid flow from DAC donars (current US$) in Micronesia in 2004 to that in 2007?
Your answer should be compact. 0.77. What is the ratio of the Aid flow from DAC donars (current US$) of Middle income in 2004 to that in 2008?
Provide a succinct answer. 0.71. What is the ratio of the Aid flow from DAC donars (current US$) in Upper middle income in 2004 to that in 2008?
Give a very brief answer. 0.74. What is the ratio of the Aid flow from DAC donars (current US$) in Middle income in 2004 to that in 2009?
Provide a short and direct response. 0.79. What is the ratio of the Aid flow from DAC donars (current US$) in Upper middle income in 2004 to that in 2009?
Your response must be concise. 1.14. What is the ratio of the Aid flow from DAC donars (current US$) in Micronesia in 2004 to that in 2009?
Offer a terse response. 0.7. What is the ratio of the Aid flow from DAC donars (current US$) in Middle income in 2005 to that in 2006?
Your answer should be very brief. 1.15. What is the ratio of the Aid flow from DAC donars (current US$) of Upper middle income in 2005 to that in 2006?
Your response must be concise. 1.68. What is the ratio of the Aid flow from DAC donars (current US$) of Micronesia in 2005 to that in 2006?
Provide a short and direct response. 0.98. What is the ratio of the Aid flow from DAC donars (current US$) in Middle income in 2005 to that in 2007?
Make the answer very short. 1.41. What is the ratio of the Aid flow from DAC donars (current US$) of Upper middle income in 2005 to that in 2007?
Provide a succinct answer. 1.68. What is the ratio of the Aid flow from DAC donars (current US$) in Micronesia in 2005 to that in 2007?
Offer a very short reply. 0.94. What is the ratio of the Aid flow from DAC donars (current US$) in Middle income in 2005 to that in 2008?
Offer a terse response. 1.26. What is the ratio of the Aid flow from DAC donars (current US$) of Upper middle income in 2005 to that in 2008?
Offer a terse response. 1.42. What is the ratio of the Aid flow from DAC donars (current US$) of Micronesia in 2005 to that in 2008?
Keep it short and to the point. 1.15. What is the ratio of the Aid flow from DAC donars (current US$) in Middle income in 2005 to that in 2009?
Keep it short and to the point. 1.4. What is the ratio of the Aid flow from DAC donars (current US$) in Upper middle income in 2005 to that in 2009?
Your answer should be very brief. 2.2. What is the ratio of the Aid flow from DAC donars (current US$) in Micronesia in 2005 to that in 2009?
Ensure brevity in your answer.  0.86. What is the ratio of the Aid flow from DAC donars (current US$) in Middle income in 2006 to that in 2007?
Your response must be concise. 1.22. What is the ratio of the Aid flow from DAC donars (current US$) in Middle income in 2006 to that in 2008?
Give a very brief answer. 1.09. What is the ratio of the Aid flow from DAC donars (current US$) of Upper middle income in 2006 to that in 2008?
Your answer should be compact. 0.85. What is the ratio of the Aid flow from DAC donars (current US$) of Micronesia in 2006 to that in 2008?
Your response must be concise. 1.17. What is the ratio of the Aid flow from DAC donars (current US$) in Middle income in 2006 to that in 2009?
Offer a very short reply. 1.21. What is the ratio of the Aid flow from DAC donars (current US$) of Upper middle income in 2006 to that in 2009?
Your answer should be very brief. 1.31. What is the ratio of the Aid flow from DAC donars (current US$) in Micronesia in 2006 to that in 2009?
Make the answer very short. 0.88. What is the ratio of the Aid flow from DAC donars (current US$) of Middle income in 2007 to that in 2008?
Your answer should be very brief. 0.89. What is the ratio of the Aid flow from DAC donars (current US$) in Upper middle income in 2007 to that in 2008?
Provide a short and direct response. 0.85. What is the ratio of the Aid flow from DAC donars (current US$) of Micronesia in 2007 to that in 2008?
Provide a short and direct response. 1.23. What is the ratio of the Aid flow from DAC donars (current US$) of Upper middle income in 2007 to that in 2009?
Your answer should be very brief. 1.31. What is the ratio of the Aid flow from DAC donars (current US$) in Micronesia in 2007 to that in 2009?
Give a very brief answer. 0.92. What is the ratio of the Aid flow from DAC donars (current US$) in Middle income in 2008 to that in 2009?
Provide a succinct answer. 1.11. What is the ratio of the Aid flow from DAC donars (current US$) of Upper middle income in 2008 to that in 2009?
Make the answer very short. 1.54. What is the ratio of the Aid flow from DAC donars (current US$) in Micronesia in 2008 to that in 2009?
Ensure brevity in your answer.  0.75. What is the difference between the highest and the second highest Aid flow from DAC donars (current US$) in Middle income?
Give a very brief answer. 7.73e+09. What is the difference between the highest and the second highest Aid flow from DAC donars (current US$) in Upper middle income?
Provide a succinct answer. 9.19e+09. What is the difference between the highest and the second highest Aid flow from DAC donars (current US$) in Micronesia?
Offer a terse response. 9.02e+06. What is the difference between the highest and the lowest Aid flow from DAC donars (current US$) in Middle income?
Give a very brief answer. 3.25e+1. What is the difference between the highest and the lowest Aid flow from DAC donars (current US$) of Upper middle income?
Make the answer very short. 2.07e+1. What is the difference between the highest and the lowest Aid flow from DAC donars (current US$) in Micronesia?
Give a very brief answer. 3.57e+07. 